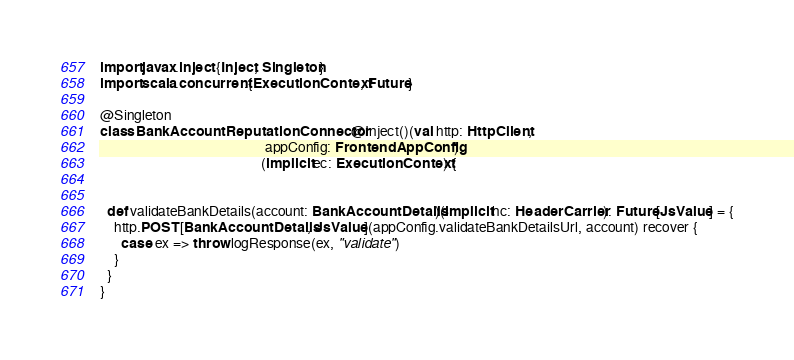<code> <loc_0><loc_0><loc_500><loc_500><_Scala_>
import javax.inject.{Inject, Singleton}
import scala.concurrent.{ExecutionContext, Future}

@Singleton
class BankAccountReputationConnector @Inject()(val http: HttpClient,
                                               appConfig: FrontendAppConfig)
                                              (implicit ec: ExecutionContext) {


  def validateBankDetails(account: BankAccountDetails)(implicit hc: HeaderCarrier): Future[JsValue] = {
    http.POST[BankAccountDetails, JsValue](appConfig.validateBankDetailsUrl, account) recover {
      case ex => throw logResponse(ex, "validate")
    }
  }
}
</code> 